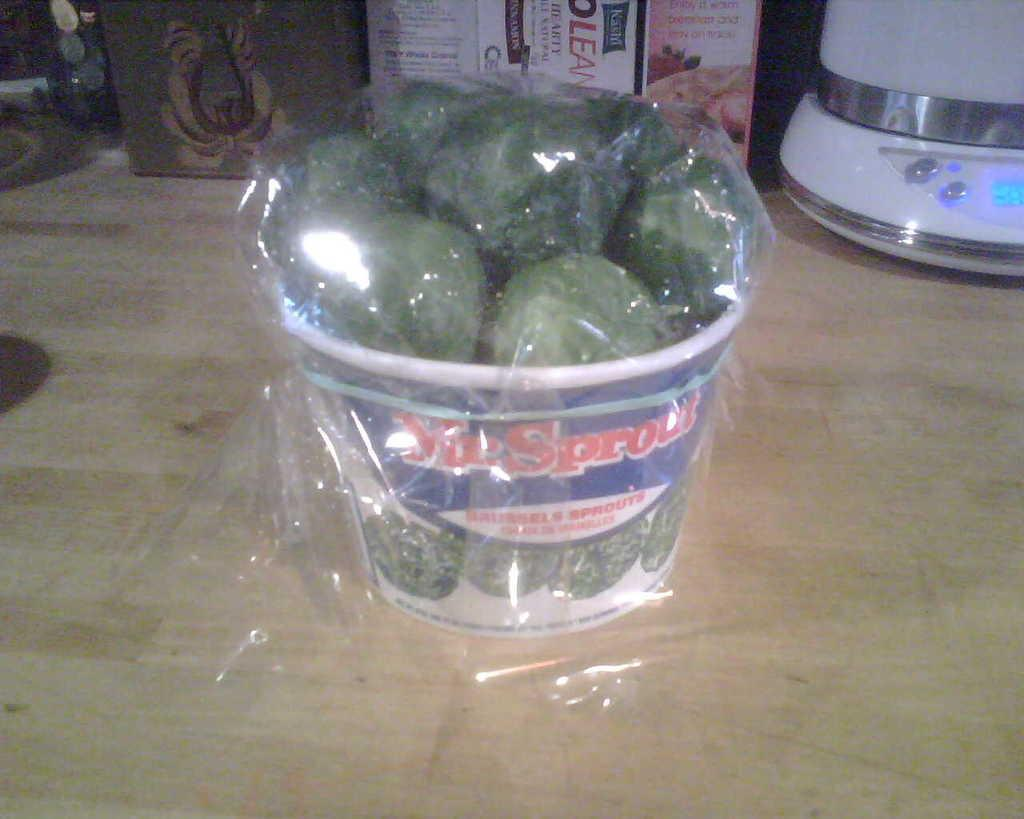What color are the objects in the box in the image? The objects in the box are green. How is the box protected or covered? The box is covered with a plastic cover. What is the box placed on in the image? The box is on a wooden platform. What can be seen in the background of the image? There are boxes and other objects in the background of the image. What type of jail is visible in the image? There is no jail present in the image. Can you describe the stranger in the image? There is no stranger present in the image. 